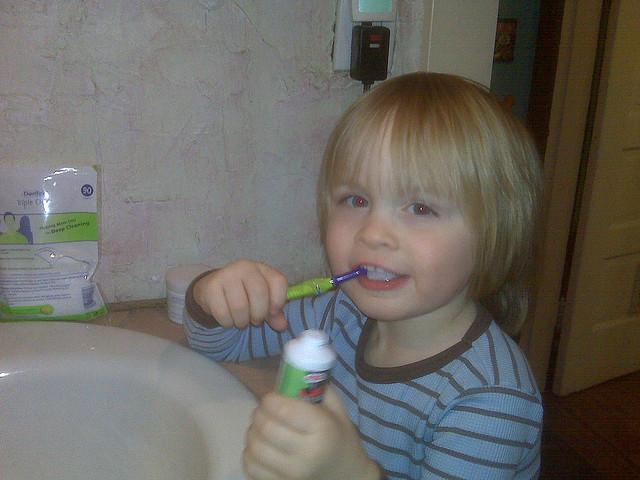What color hair does the child have?
Concise answer only. Blonde. What character is on the babies brush?
Quick response, please. None. What is the baby doing?
Keep it brief. Brushing teeth. What is the child holding in her left hand?
Quick response, please. Toothpaste. 